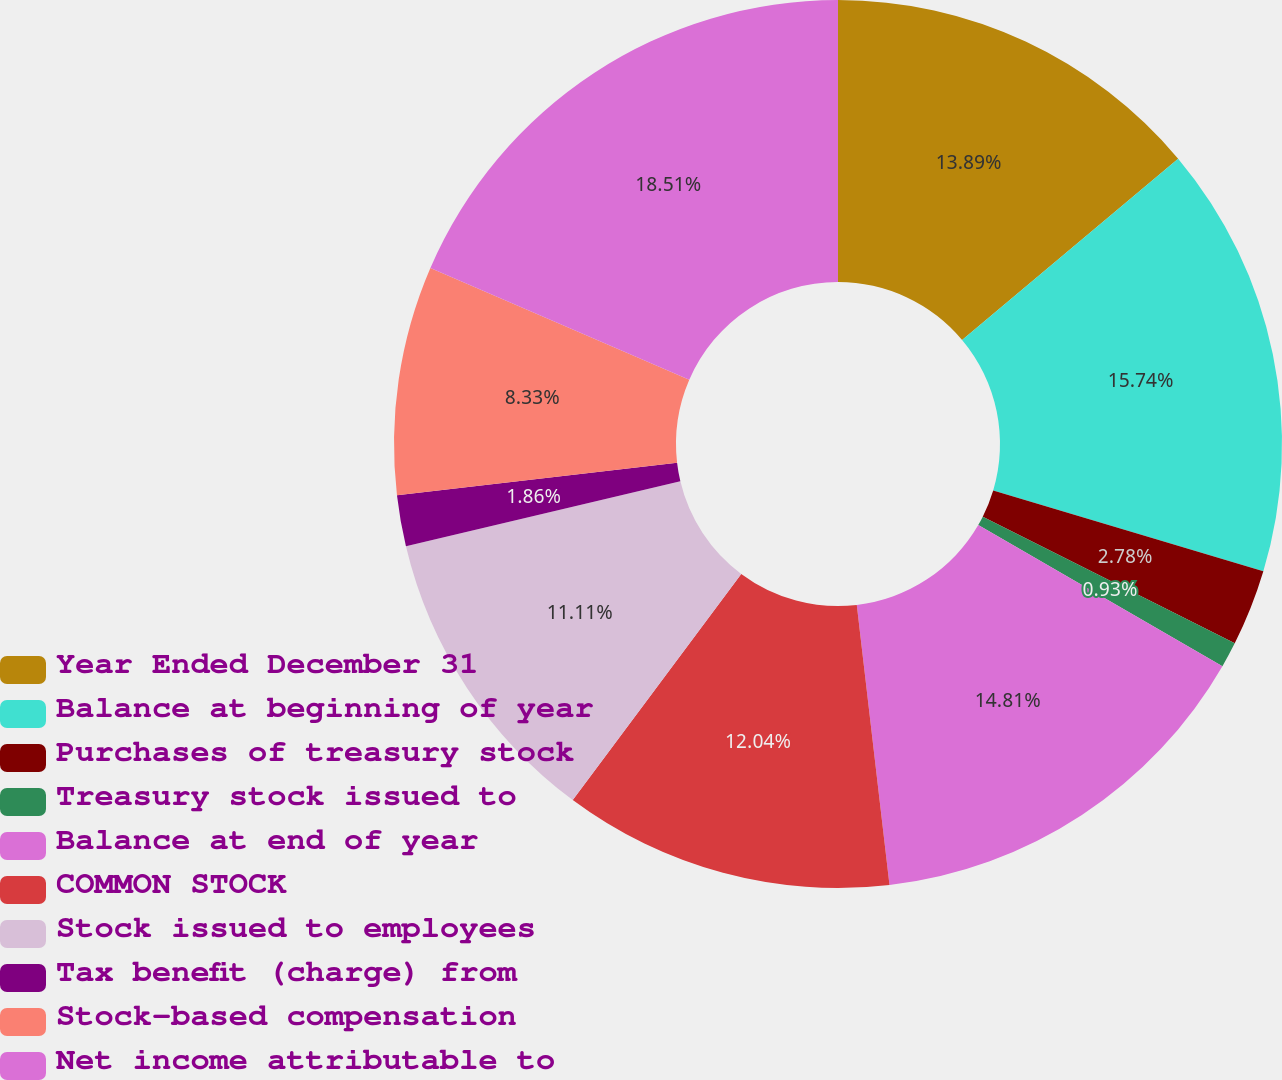Convert chart to OTSL. <chart><loc_0><loc_0><loc_500><loc_500><pie_chart><fcel>Year Ended December 31<fcel>Balance at beginning of year<fcel>Purchases of treasury stock<fcel>Treasury stock issued to<fcel>Balance at end of year<fcel>COMMON STOCK<fcel>Stock issued to employees<fcel>Tax benefit (charge) from<fcel>Stock-based compensation<fcel>Net income attributable to<nl><fcel>13.89%<fcel>15.74%<fcel>2.78%<fcel>0.93%<fcel>14.81%<fcel>12.04%<fcel>11.11%<fcel>1.86%<fcel>8.33%<fcel>18.51%<nl></chart> 